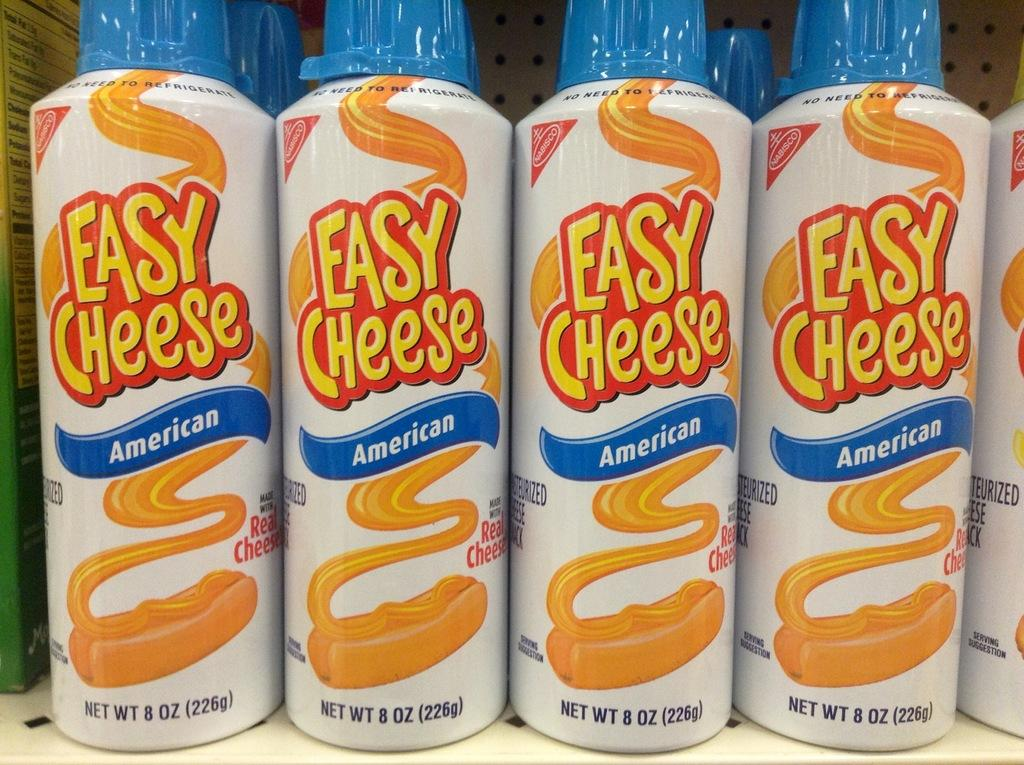What type of food-related items are present in the image? There are cheese bottles in the image. What can be found on the cheese bottles? The cheese bottles have text on them and weight information. What other item is present in the image? There is a book in the image. What is the color of the surface on which the cheese bottles and book are placed? The cheese bottles and book are placed on a white surface. How many girls are wearing suits in the image? There are no girls or suits present in the image. What number is written on the book in the image? The provided facts do not mention any numbers on the book, only that it is present in the image. 